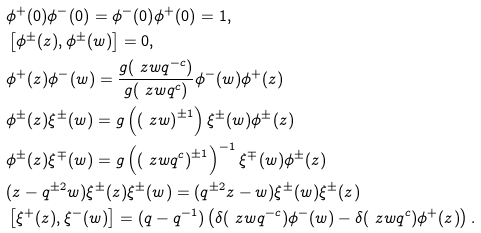<formula> <loc_0><loc_0><loc_500><loc_500>& \phi ^ { + } ( 0 ) \phi ^ { - } ( 0 ) = \phi ^ { - } ( 0 ) \phi ^ { + } ( 0 ) = 1 , \\ & \left [ \phi ^ { \pm } ( z ) , \phi ^ { \pm } ( w ) \right ] = 0 , \\ & \phi ^ { + } ( z ) \phi ^ { - } ( w ) = \frac { g ( \ z w q ^ { - c } ) } { g ( \ z w q ^ { c } ) } \phi ^ { - } ( w ) \phi ^ { + } ( z ) \\ & \phi ^ { \pm } ( z ) \xi ^ { \pm } ( w ) = g \left ( \left ( \ z w \right ) ^ { \pm 1 } \right ) \xi ^ { \pm } ( w ) \phi ^ { \pm } ( z ) \\ & \phi ^ { \pm } ( z ) \xi ^ { \mp } ( w ) = g \left ( \left ( \ z w q ^ { c } \right ) ^ { \pm 1 } \right ) ^ { - 1 } \xi ^ { \mp } ( w ) \phi ^ { \pm } ( z ) \\ & ( z - q ^ { \pm 2 } w ) \xi ^ { \pm } ( z ) \xi ^ { \pm } ( w ) = ( q ^ { \pm 2 } z - w ) \xi ^ { \pm } ( w ) \xi ^ { \pm } ( z ) \\ & \left [ \xi ^ { + } ( z ) , \xi ^ { - } ( w ) \right ] = ( q - q ^ { - 1 } ) \left ( \delta ( \ z w q ^ { - c } ) \phi ^ { - } ( w ) - \delta ( \ z w q ^ { c } ) \phi ^ { + } ( z ) \right ) . \\</formula> 